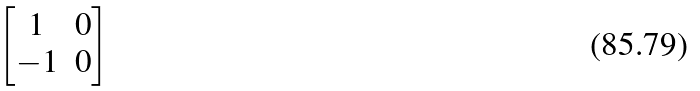Convert formula to latex. <formula><loc_0><loc_0><loc_500><loc_500>\begin{bmatrix} 1 & 0 \\ - 1 & 0 \end{bmatrix}</formula> 